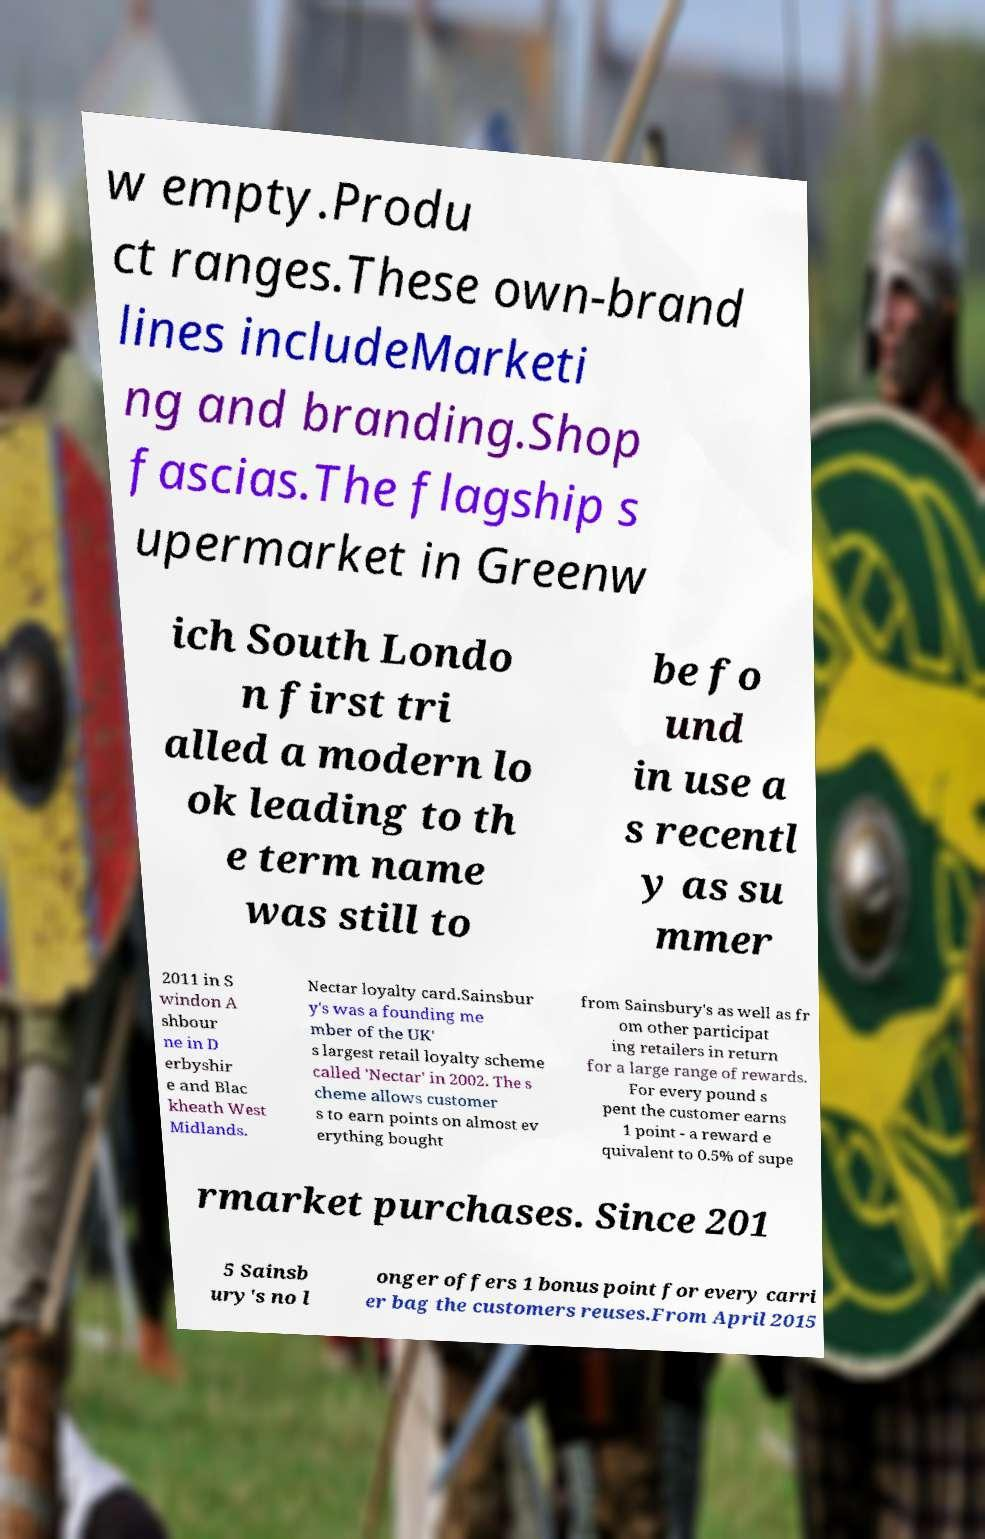Please read and relay the text visible in this image. What does it say? w empty.Produ ct ranges.These own-brand lines includeMarketi ng and branding.Shop fascias.The flagship s upermarket in Greenw ich South Londo n first tri alled a modern lo ok leading to th e term name was still to be fo und in use a s recentl y as su mmer 2011 in S windon A shbour ne in D erbyshir e and Blac kheath West Midlands. Nectar loyalty card.Sainsbur y's was a founding me mber of the UK' s largest retail loyalty scheme called 'Nectar' in 2002. The s cheme allows customer s to earn points on almost ev erything bought from Sainsbury's as well as fr om other participat ing retailers in return for a large range of rewards. For every pound s pent the customer earns 1 point - a reward e quivalent to 0.5% of supe rmarket purchases. Since 201 5 Sainsb ury's no l onger offers 1 bonus point for every carri er bag the customers reuses.From April 2015 